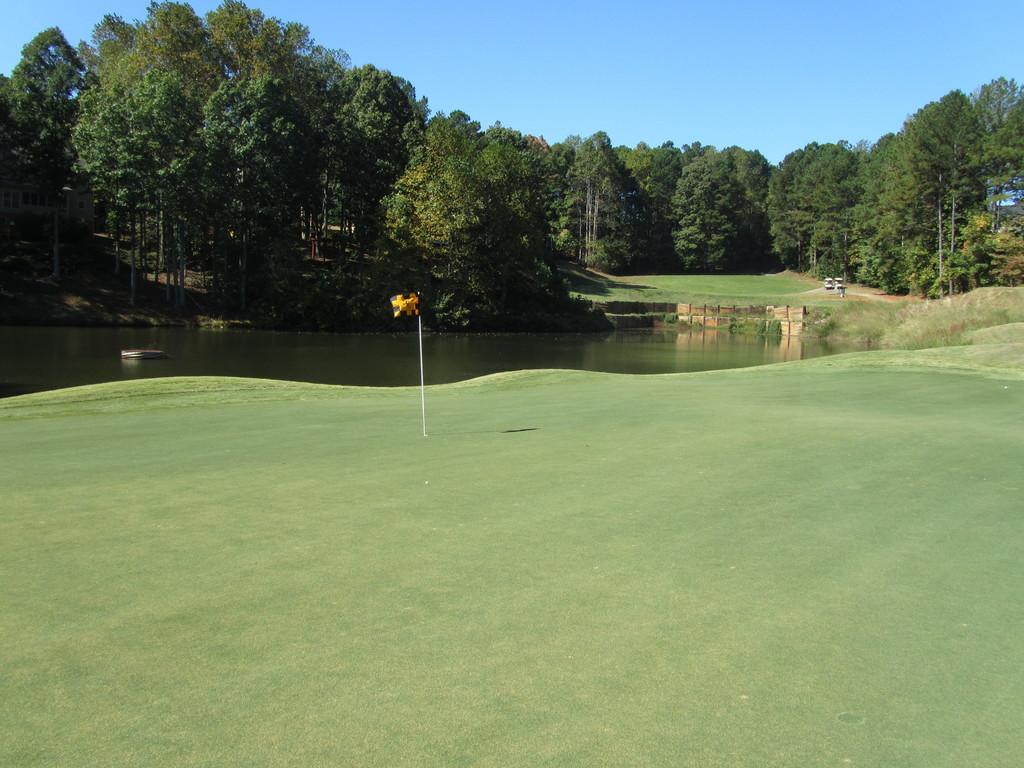What body of water is visible in the image? There is a lake in the image. What type of vegetation can be seen around the lake? There are plants and trees around the lake. What is the ground surface like in the image? There is grass on the floor in the image. What type of bean is growing on the trees in the image? There are no beans growing on the trees in the image; it features a lake with plants and trees around it. How many legs can be seen in the image? There are no legs visible in the image; it only shows a lake, plants, trees, and grass. 